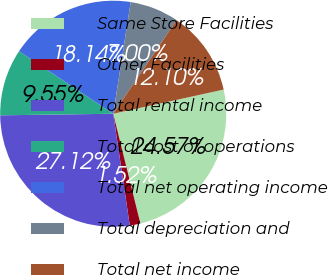Convert chart. <chart><loc_0><loc_0><loc_500><loc_500><pie_chart><fcel>Same Store Facilities<fcel>Other Facilities<fcel>Total rental income<fcel>Total cost of operations<fcel>Total net operating income<fcel>Total depreciation and<fcel>Total net income<nl><fcel>24.57%<fcel>1.52%<fcel>27.12%<fcel>9.55%<fcel>18.14%<fcel>7.0%<fcel>12.1%<nl></chart> 